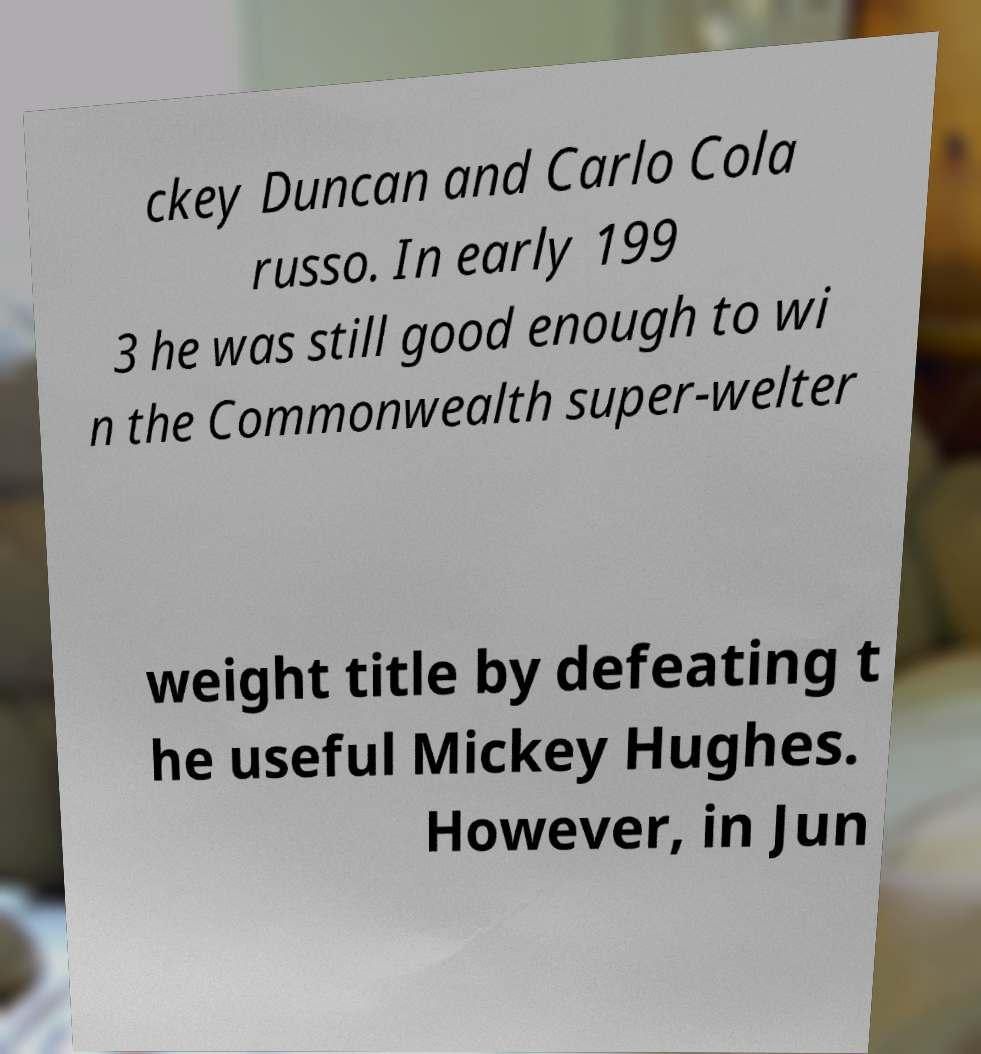There's text embedded in this image that I need extracted. Can you transcribe it verbatim? ckey Duncan and Carlo Cola russo. In early 199 3 he was still good enough to wi n the Commonwealth super-welter weight title by defeating t he useful Mickey Hughes. However, in Jun 